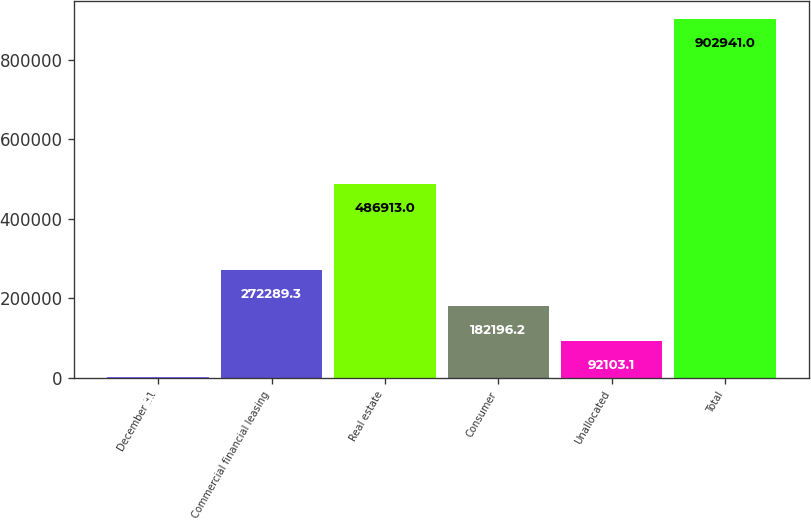Convert chart to OTSL. <chart><loc_0><loc_0><loc_500><loc_500><bar_chart><fcel>December 31<fcel>Commercial financial leasing<fcel>Real estate<fcel>Consumer<fcel>Unallocated<fcel>Total<nl><fcel>2010<fcel>272289<fcel>486913<fcel>182196<fcel>92103.1<fcel>902941<nl></chart> 